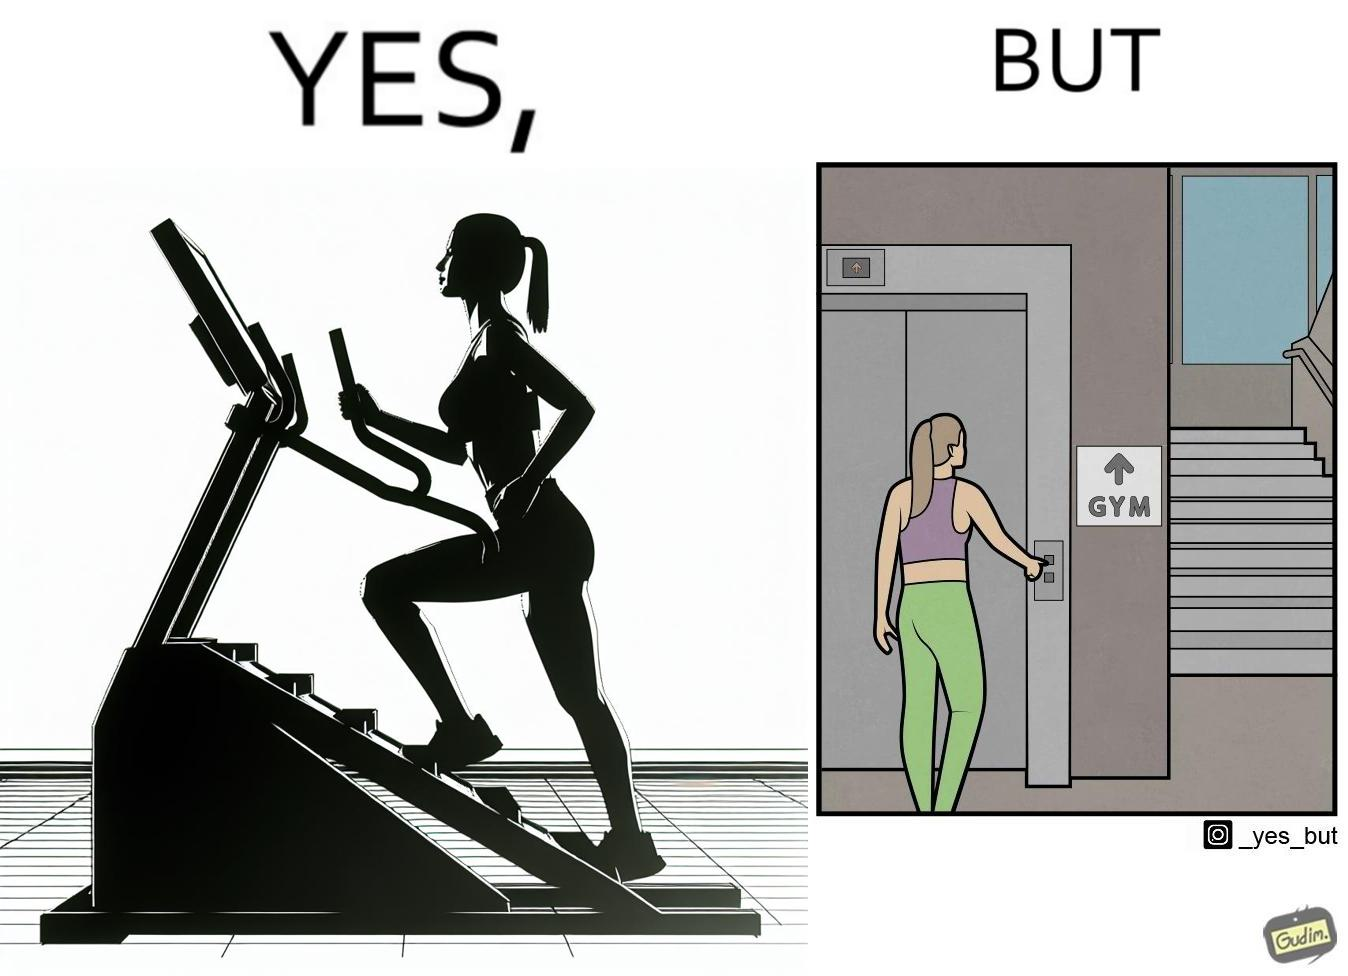What is shown in the left half versus the right half of this image? In the left part of the image: a woman is seen using the stair climber machine at some gym In the right part of the image: a woman calling for the lift to avoid climbing up the stairs for going to the gym 